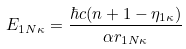<formula> <loc_0><loc_0><loc_500><loc_500>E _ { 1 N \kappa } = \frac { \hbar { c } ( n + 1 - \eta _ { 1 \kappa } ) } { \alpha r _ { 1 N \kappa } }</formula> 